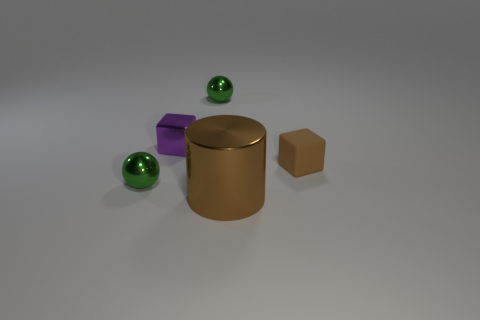What material is the cube that is the same color as the large object?
Make the answer very short. Rubber. There is a tiny block to the left of the brown shiny thing left of the brown block; what is its material?
Ensure brevity in your answer.  Metal. There is a metallic object that is the same shape as the brown rubber thing; what size is it?
Offer a very short reply. Small. Is the tiny matte object the same color as the large thing?
Keep it short and to the point. Yes. There is a small object that is both behind the brown block and on the right side of the purple metallic object; what color is it?
Offer a very short reply. Green. Is the size of the green metal ball that is in front of the purple cube the same as the metallic block?
Offer a very short reply. Yes. Is there any other thing that has the same shape as the large brown object?
Make the answer very short. No. Is the purple object made of the same material as the green sphere to the right of the purple metal block?
Provide a succinct answer. Yes. What number of gray objects are matte blocks or metal cylinders?
Provide a short and direct response. 0. Are any small yellow blocks visible?
Keep it short and to the point. No. 